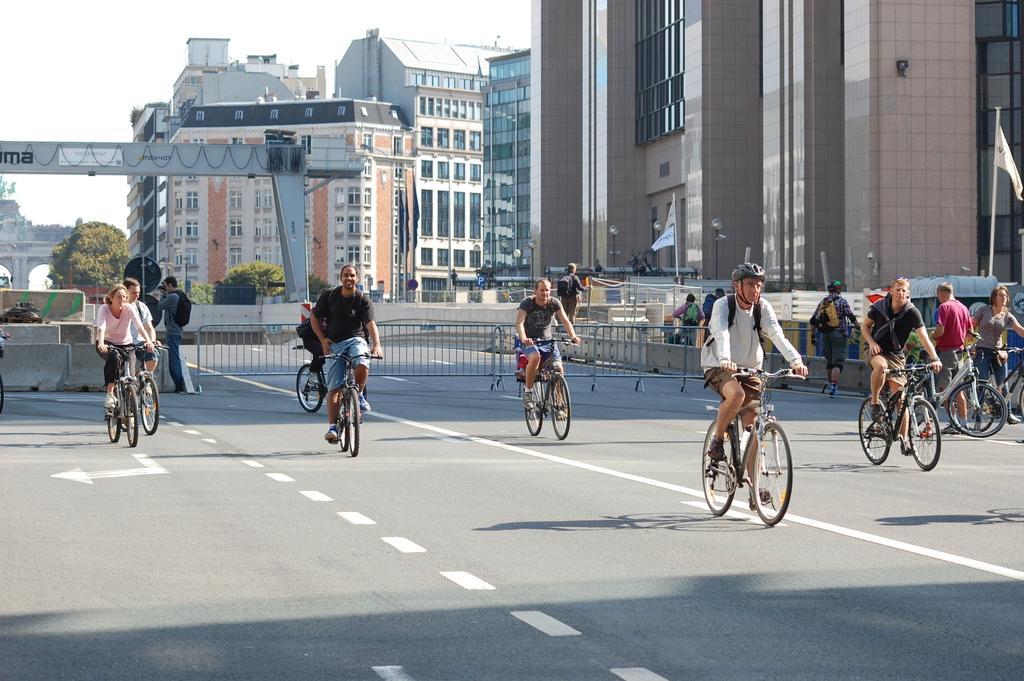In one or two sentences, can you explain what this image depicts? In this image we can see a group of people riding bicycles. In the center of the image we can see some people standing on the road, one person is holding a camera in his hand. On the right side of the image we can see some flags on poles. In the background, we can see a group of buildings with windows, metal frames and group of trees. At the top of the image we can see the sky. 